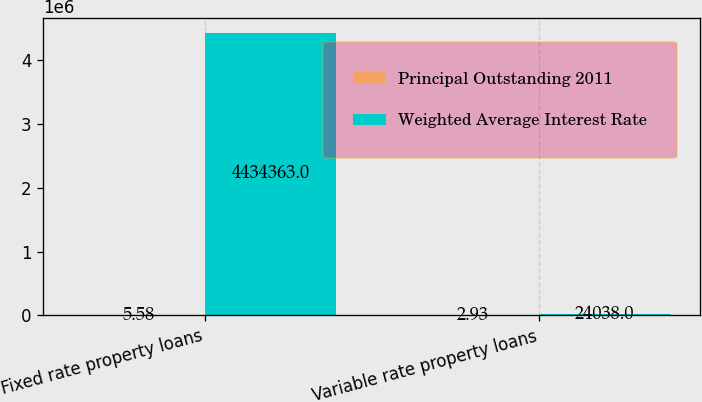Convert chart. <chart><loc_0><loc_0><loc_500><loc_500><stacked_bar_chart><ecel><fcel>Fixed rate property loans<fcel>Variable rate property loans<nl><fcel>Principal Outstanding 2011<fcel>5.58<fcel>2.93<nl><fcel>Weighted Average Interest Rate<fcel>4.43436e+06<fcel>24038<nl></chart> 